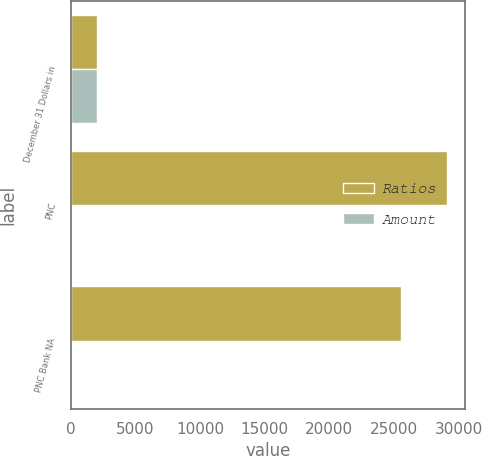Convert chart to OTSL. <chart><loc_0><loc_0><loc_500><loc_500><stacked_bar_chart><ecel><fcel>December 31 Dollars in<fcel>PNC<fcel>PNC Bank NA<nl><fcel>Ratios<fcel>2011<fcel>29073<fcel>25536<nl><fcel>Amount<fcel>2011<fcel>12.6<fcel>11.4<nl></chart> 